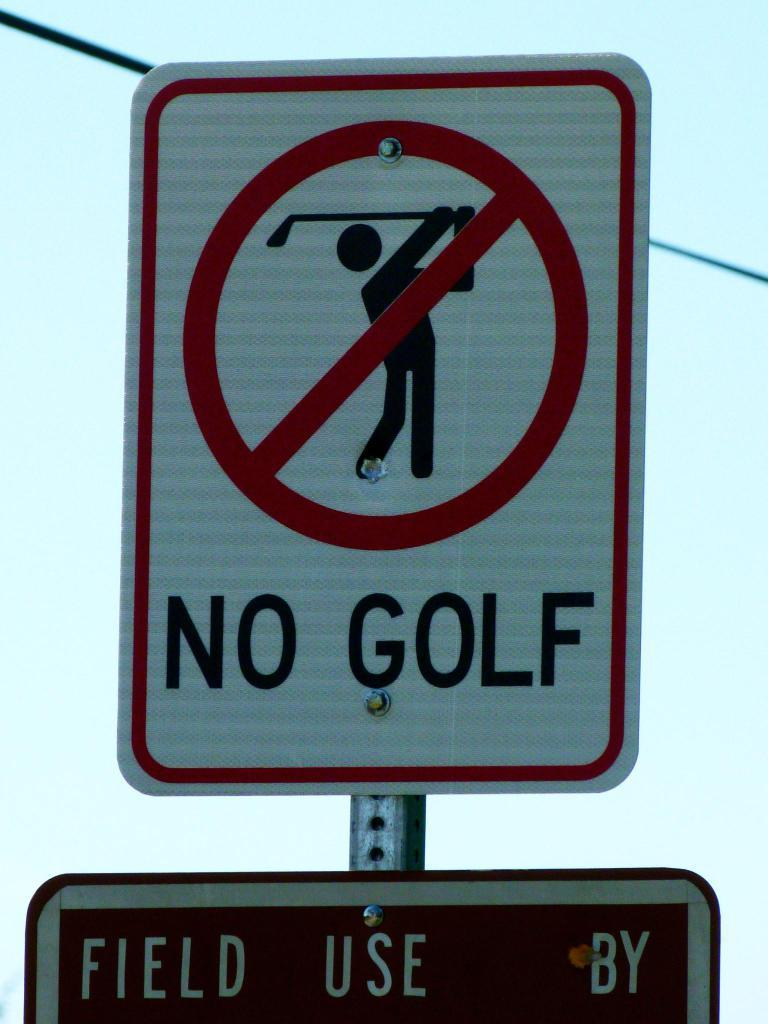<image>
Give a short and clear explanation of the subsequent image. A close up of a red and white no golfing sign. 